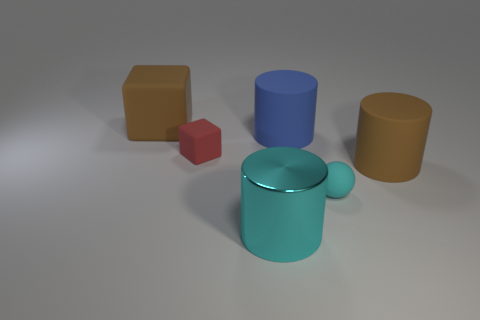Add 1 large red matte cylinders. How many objects exist? 7 Subtract all spheres. How many objects are left? 5 Subtract all large blue rubber cylinders. Subtract all big brown matte blocks. How many objects are left? 4 Add 5 big brown rubber objects. How many big brown rubber objects are left? 7 Add 3 tiny yellow metallic balls. How many tiny yellow metallic balls exist? 3 Subtract 0 brown spheres. How many objects are left? 6 